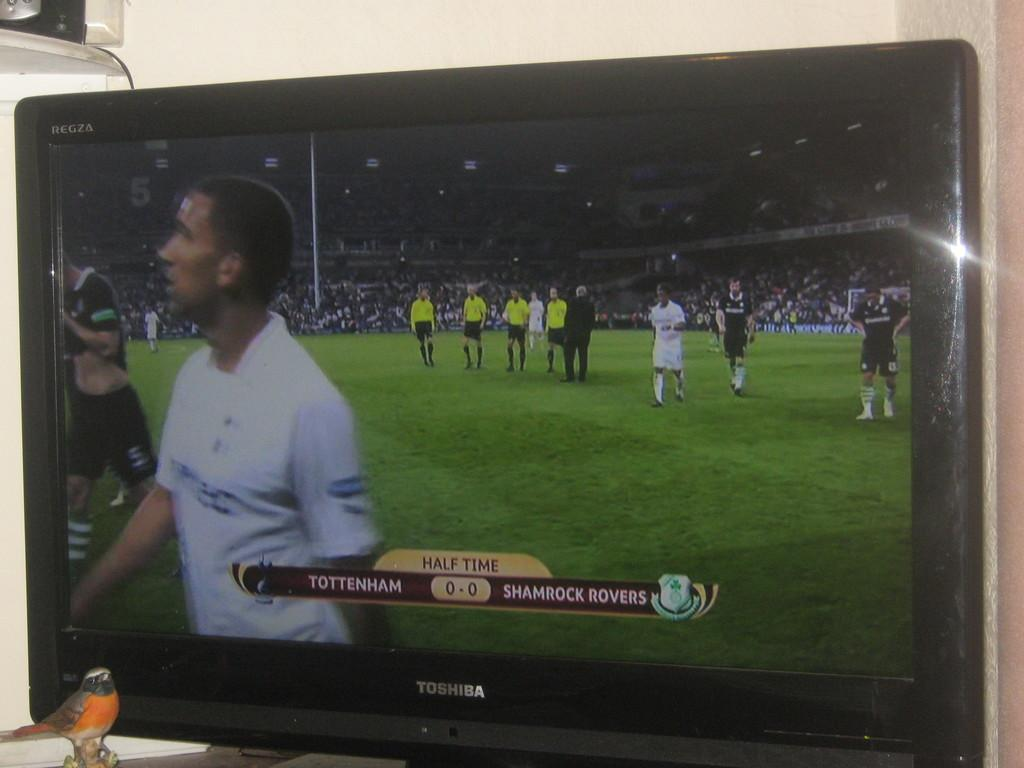<image>
Offer a succinct explanation of the picture presented. The players are coming off the field at half time. 